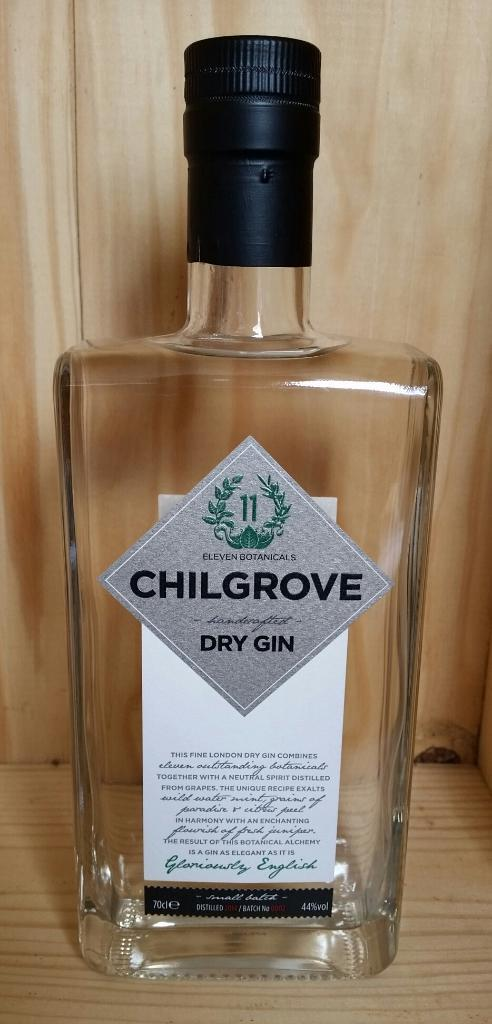Provide a one-sentence caption for the provided image. Empty bottle of Chilgrove Dry Gin is depicted. 